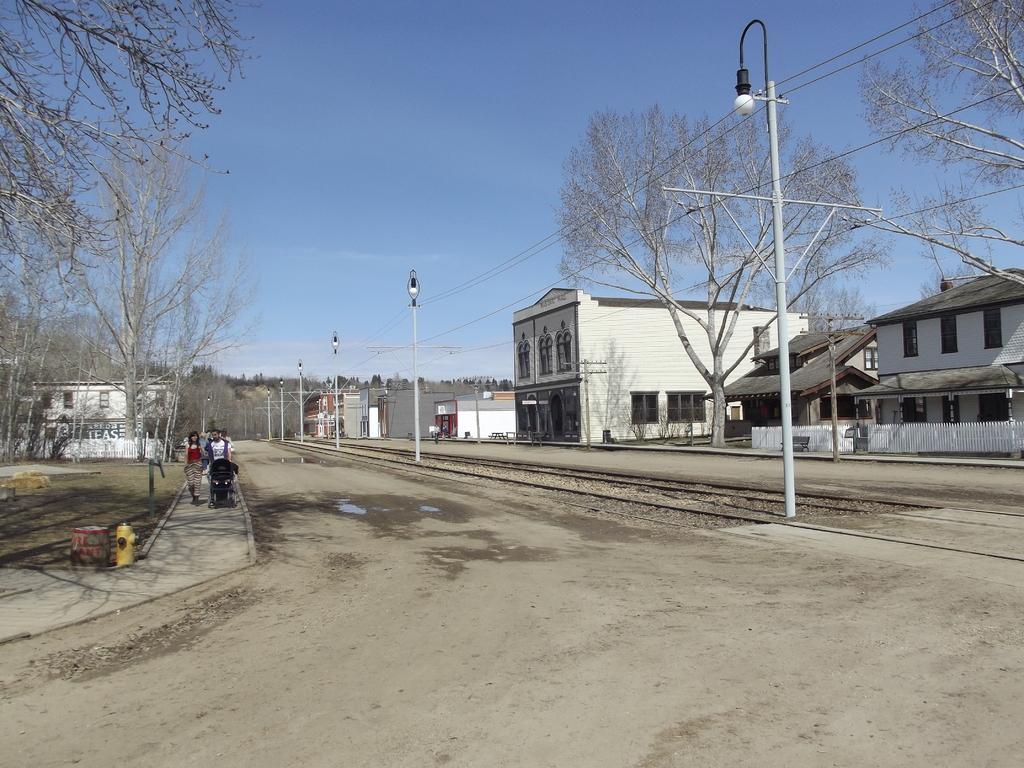How would you summarize this image in a sentence or two? In the foreground I can see a group of people on the road, street lights, wires, houses, buildings and trees. At the top I can see the sky. This image is taken during a day. 